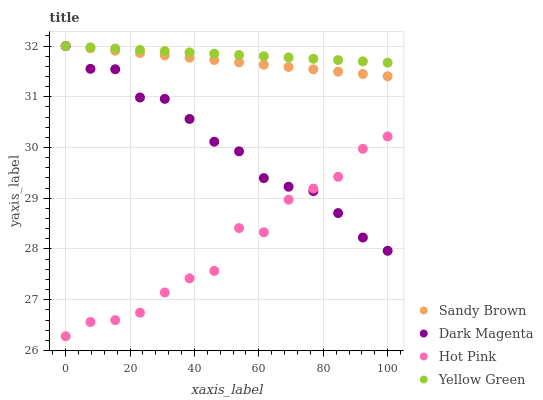Does Hot Pink have the minimum area under the curve?
Answer yes or no. Yes. Does Yellow Green have the maximum area under the curve?
Answer yes or no. Yes. Does Sandy Brown have the minimum area under the curve?
Answer yes or no. No. Does Sandy Brown have the maximum area under the curve?
Answer yes or no. No. Is Yellow Green the smoothest?
Answer yes or no. Yes. Is Hot Pink the roughest?
Answer yes or no. Yes. Is Sandy Brown the smoothest?
Answer yes or no. No. Is Sandy Brown the roughest?
Answer yes or no. No. Does Hot Pink have the lowest value?
Answer yes or no. Yes. Does Sandy Brown have the lowest value?
Answer yes or no. No. Does Yellow Green have the highest value?
Answer yes or no. Yes. Is Hot Pink less than Yellow Green?
Answer yes or no. Yes. Is Yellow Green greater than Hot Pink?
Answer yes or no. Yes. Does Hot Pink intersect Dark Magenta?
Answer yes or no. Yes. Is Hot Pink less than Dark Magenta?
Answer yes or no. No. Is Hot Pink greater than Dark Magenta?
Answer yes or no. No. Does Hot Pink intersect Yellow Green?
Answer yes or no. No. 